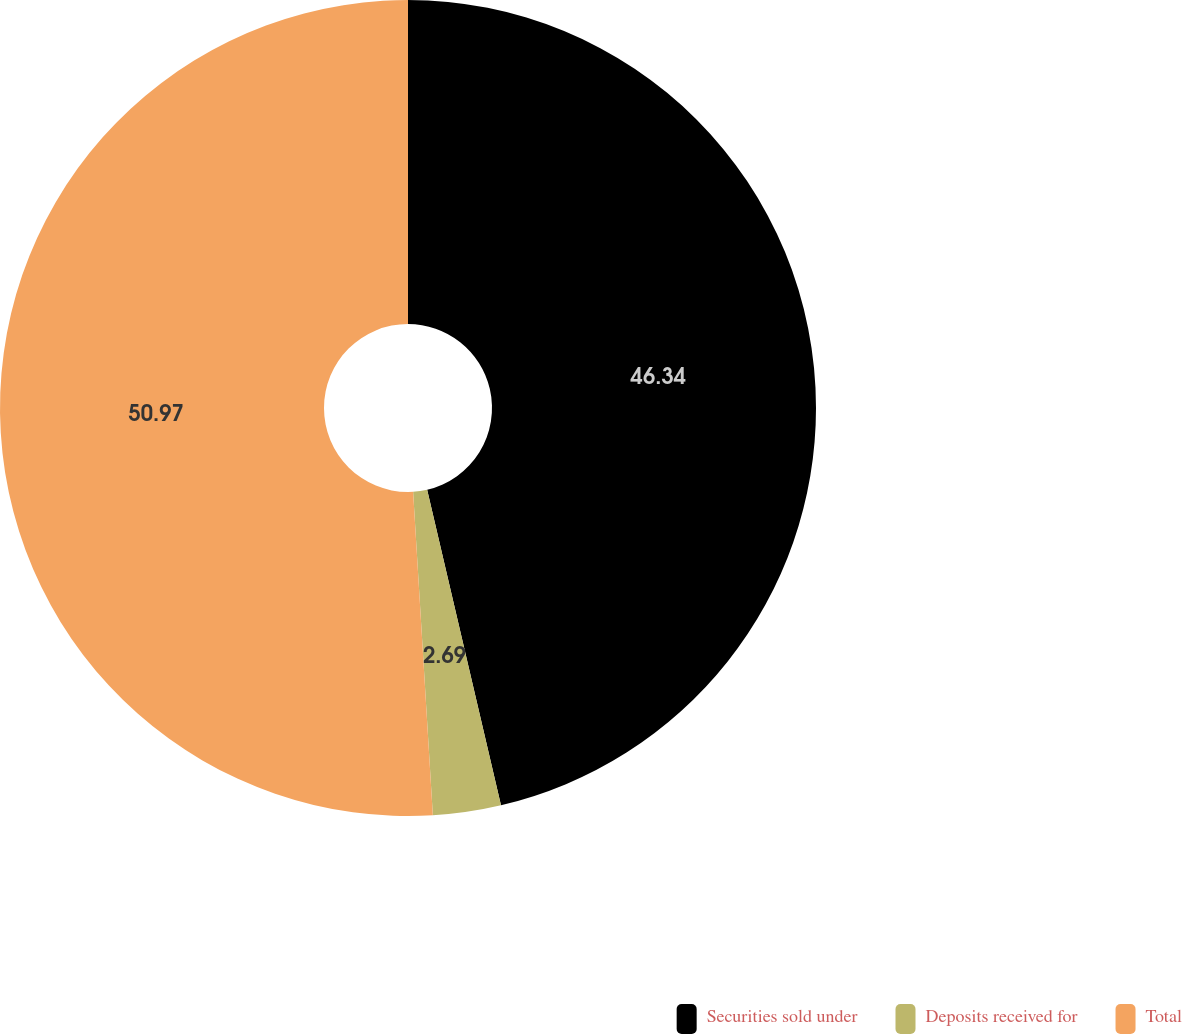Convert chart. <chart><loc_0><loc_0><loc_500><loc_500><pie_chart><fcel>Securities sold under<fcel>Deposits received for<fcel>Total<nl><fcel>46.34%<fcel>2.69%<fcel>50.97%<nl></chart> 